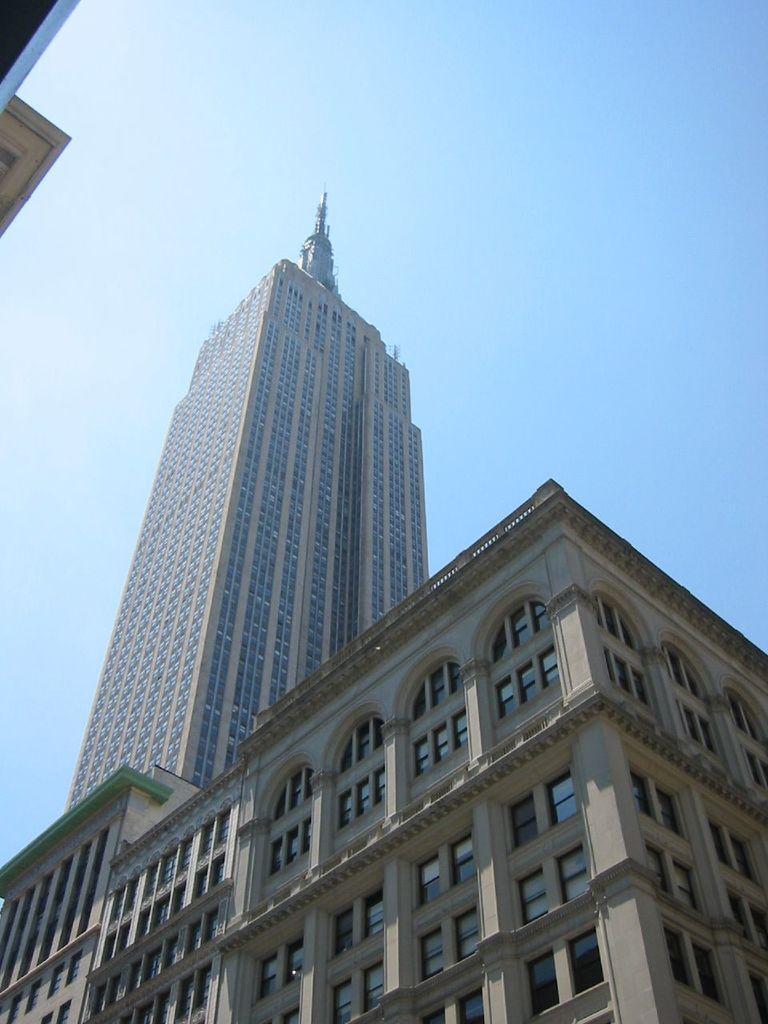Can you describe this image briefly? In the center of the image there is a building. At the top of the image there is sky. 